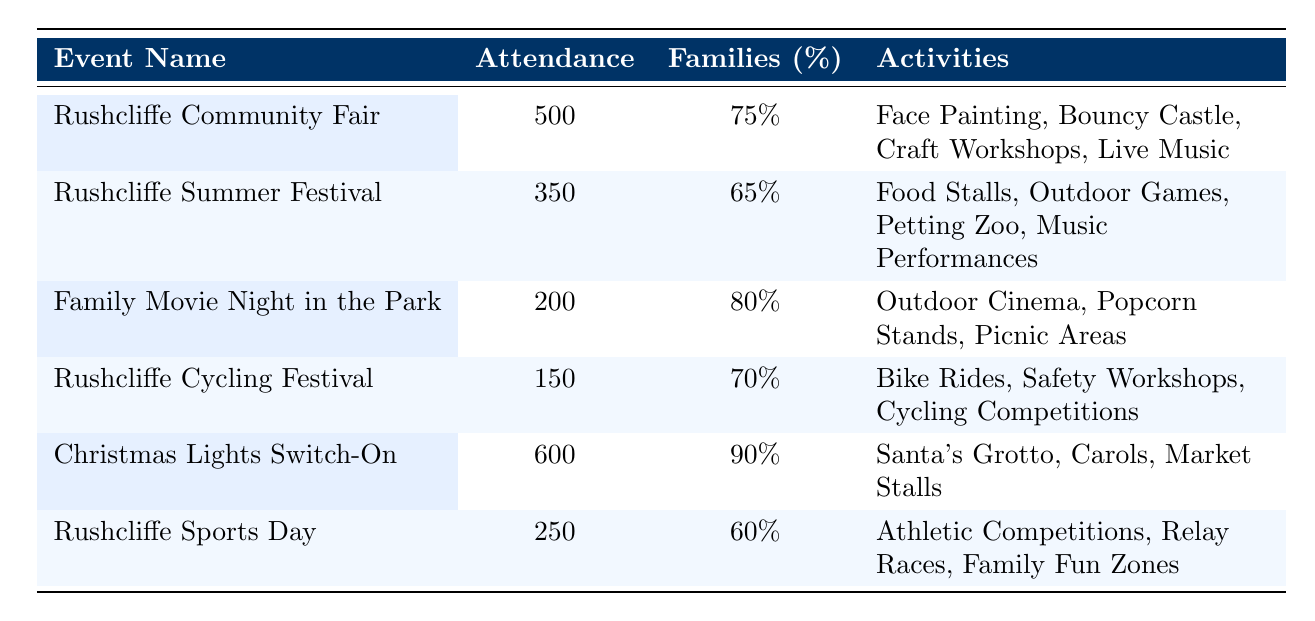What's the attendance at the Christmas Lights Switch-On event? The table lists that the Christmas Lights Switch-On event had an attendance of 600 people.
Answer: 600 What percentage of families attended the Family Movie Night in the Park? The table indicates that 80% of families attended the Family Movie Night in the Park.
Answer: 80% Which event had the highest percentage of family attendance? By reviewing the percentages, the event with the highest family attendance is the Christmas Lights Switch-On with 90%.
Answer: Christmas Lights Switch-On How many total families attended the Rushcliffe Community Fair and the Rushcliffe Summer Festival? The attendance for the Community Fair is 500 and for the Summer Festival is 350. Adding these together gives 500 + 350 = 850.
Answer: 850 Is the Rushcliffe Cycling Festival more popular among families than the Rushcliffe Sports Day? The Rushcliffe Cycling Festival had 70% of families attending while the Sports Day had 60%. Thus, yes, it is more popular among families.
Answer: Yes What is the average percentage of family attendance across all events? To find the average, sum the percentages: 75 + 65 + 80 + 70 + 90 + 60 = 450. There are 6 events, so the average is 450 / 6 = 75%.
Answer: 75% Which event had the least attendance and what was the percentage of families? The event with the least attendance was the Rushcliffe Cycling Festival with 150 attendees and 70% family attendance.
Answer: Rushcliffe Cycling Festival, 70% How many more families attended the Christmas Lights Switch-On compared to the Rushcliffe Sports Day? The Christmas Lights Switch-On had 600 attendees and the Sports Day had 250 attendees. The difference is 600 - 250 = 350.
Answer: 350 Were there any events that had an attendance of less than 300 families? Yes, the Rushcliffe Cycling Festival (150) and Family Movie Night in the Park (200) both had less than 300 attendees.
Answer: Yes 